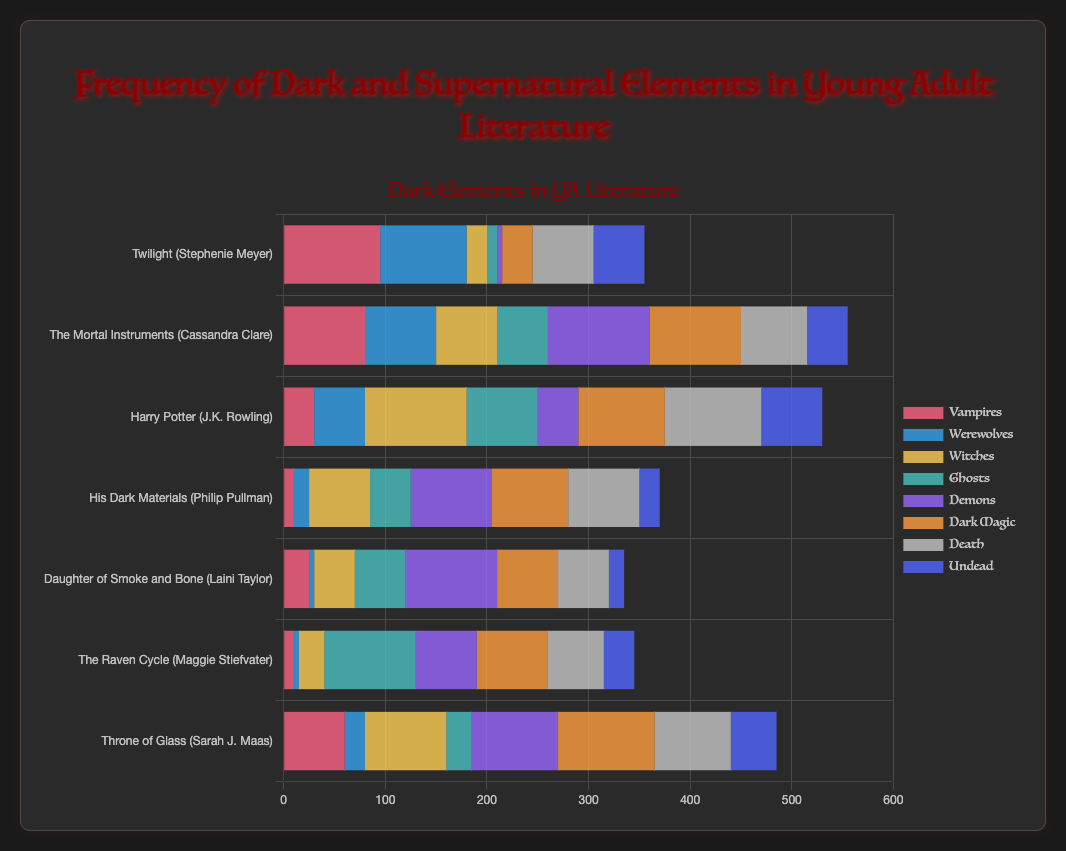What's the total frequency of dark and supernatural elements in "Twilight"? Add up the frequencies for all elements in "Twilight": Vampires (95) + Werewolves (85) + Witches (20) + Ghosts (10) + Demons (5) + Dark Magic (30) + Death (60) + Undead (50) = 355
Answer: 355 Which book has the highest frequency of "Witches"? Compare the frequency of "Witches" across all books. "Harry Potter" has the highest with a frequency of 100.
Answer: Harry Potter How does the frequency of "Vampires" compare between "Twilight" and "The Mortal Instruments"? "Twilight" has a Vampires frequency of 95 and "The Mortal Instruments" has 80. Compare these numbers and "Twilight" has a higher frequency.
Answer: Twilight Which book features "Demons" the most, and what is its frequency? Identify the frequency of Demons in each book. "The Mortal Instruments" has the highest with a frequency of 100.
Answer: The Mortal Instruments, 100 What is the average frequency of "Dark Magic" across all books? Add the frequencies of Dark Magic across all books: 30 + 90 + 85 + 75 + 60 + 70 + 95 = 505. Then, divide by the number of books (7). 505 / 7 ≈ 72.14
Answer: 72.14 Which book has the lowest frequency of "Ghosts"? Compare the Ghosts frequency in each book. "Twilight" has the lowest frequency of Ghosts with 10.
Answer: Twilight What is the combined frequency of "Werewolves" and "Undead" in "Throne of Glass"? Add the frequencies of Werewolves and Undead in "Throne of Glass": Werewolves (20) + Undead (45) = 65
Answer: 65 Compare the frequency of "Death" between "Harry Potter" and "His Dark Materials". Which one is higher? "Harry Potter" has a frequency of 95 and "His Dark Materials" has 70. "Harry Potter" has a higher frequency.
Answer: Harry Potter Which element is depicted in the palest shade in the chart, and can you name a book with its highest frequency? The palest shade corresponds to "Death". "Harry Potter" depicts the highest frequency of "Death" at 95.
Answer: Death, Harry Potter Which book has a higher frequency of dark elements: "The Raven Cycle" or "Daughter of Smoke and Bone"? Calculate the total frequency of dark elements in both books and compare: "The Raven Cycle" (10 + 5 + 25 + 90 + 60 + 70 + 55 + 30 = 345) and "Daughter of Smoke and Bone" (25 + 5 + 40 + 50 + 90 + 60 + 50 + 15 = 335). "The Raven Cycle" has a higher frequency.
Answer: The Raven Cycle 